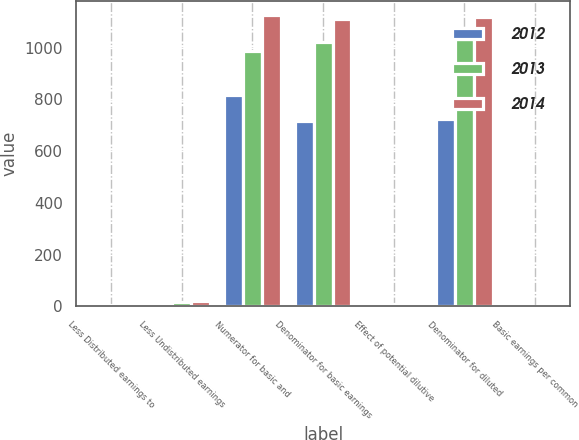Convert chart. <chart><loc_0><loc_0><loc_500><loc_500><stacked_bar_chart><ecel><fcel>Less Distributed earnings to<fcel>Less Undistributed earnings<fcel>Numerator for basic and<fcel>Denominator for basic earnings<fcel>Effect of potential dilutive<fcel>Denominator for diluted<fcel>Basic earnings per common<nl><fcel>2012<fcel>4<fcel>14<fcel>817<fcel>716<fcel>10<fcel>726<fcel>1.14<nl><fcel>2013<fcel>5<fcel>18<fcel>987<fcel>1024<fcel>11<fcel>1035<fcel>0.96<nl><fcel>2014<fcel>4<fcel>20<fcel>1125<fcel>1112<fcel>6<fcel>1118<fcel>1.01<nl></chart> 